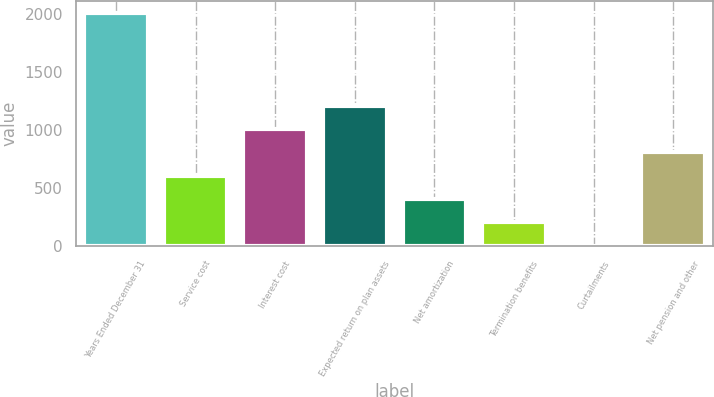Convert chart. <chart><loc_0><loc_0><loc_500><loc_500><bar_chart><fcel>Years Ended December 31<fcel>Service cost<fcel>Interest cost<fcel>Expected return on plan assets<fcel>Net amortization<fcel>Termination benefits<fcel>Curtailments<fcel>Net pension and other<nl><fcel>2008<fcel>606.39<fcel>1006.85<fcel>1207.08<fcel>406.16<fcel>205.93<fcel>5.7<fcel>806.62<nl></chart> 